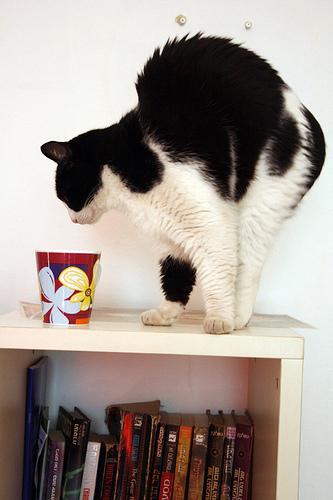How many of the cat's feet are showing?
Write a very short answer. 3. What is on the shelf below the cat?
Give a very brief answer. Books. Is the cat drinking from the mug?
Write a very short answer. Yes. 